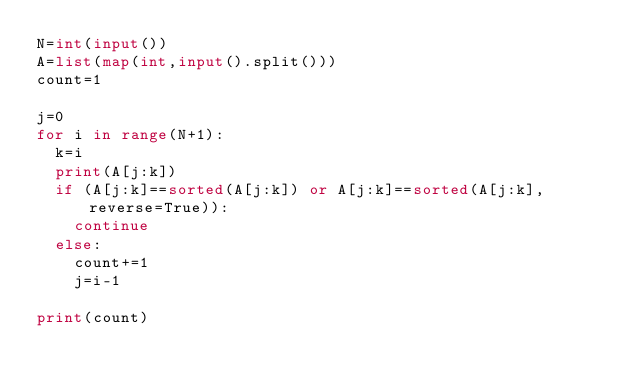<code> <loc_0><loc_0><loc_500><loc_500><_Python_>N=int(input())
A=list(map(int,input().split()))
count=1

j=0
for i in range(N+1):
  k=i
  print(A[j:k])
  if (A[j:k]==sorted(A[j:k]) or A[j:k]==sorted(A[j:k],reverse=True)):
    continue
  else:
    count+=1
    j=i-1
    
print(count)</code> 